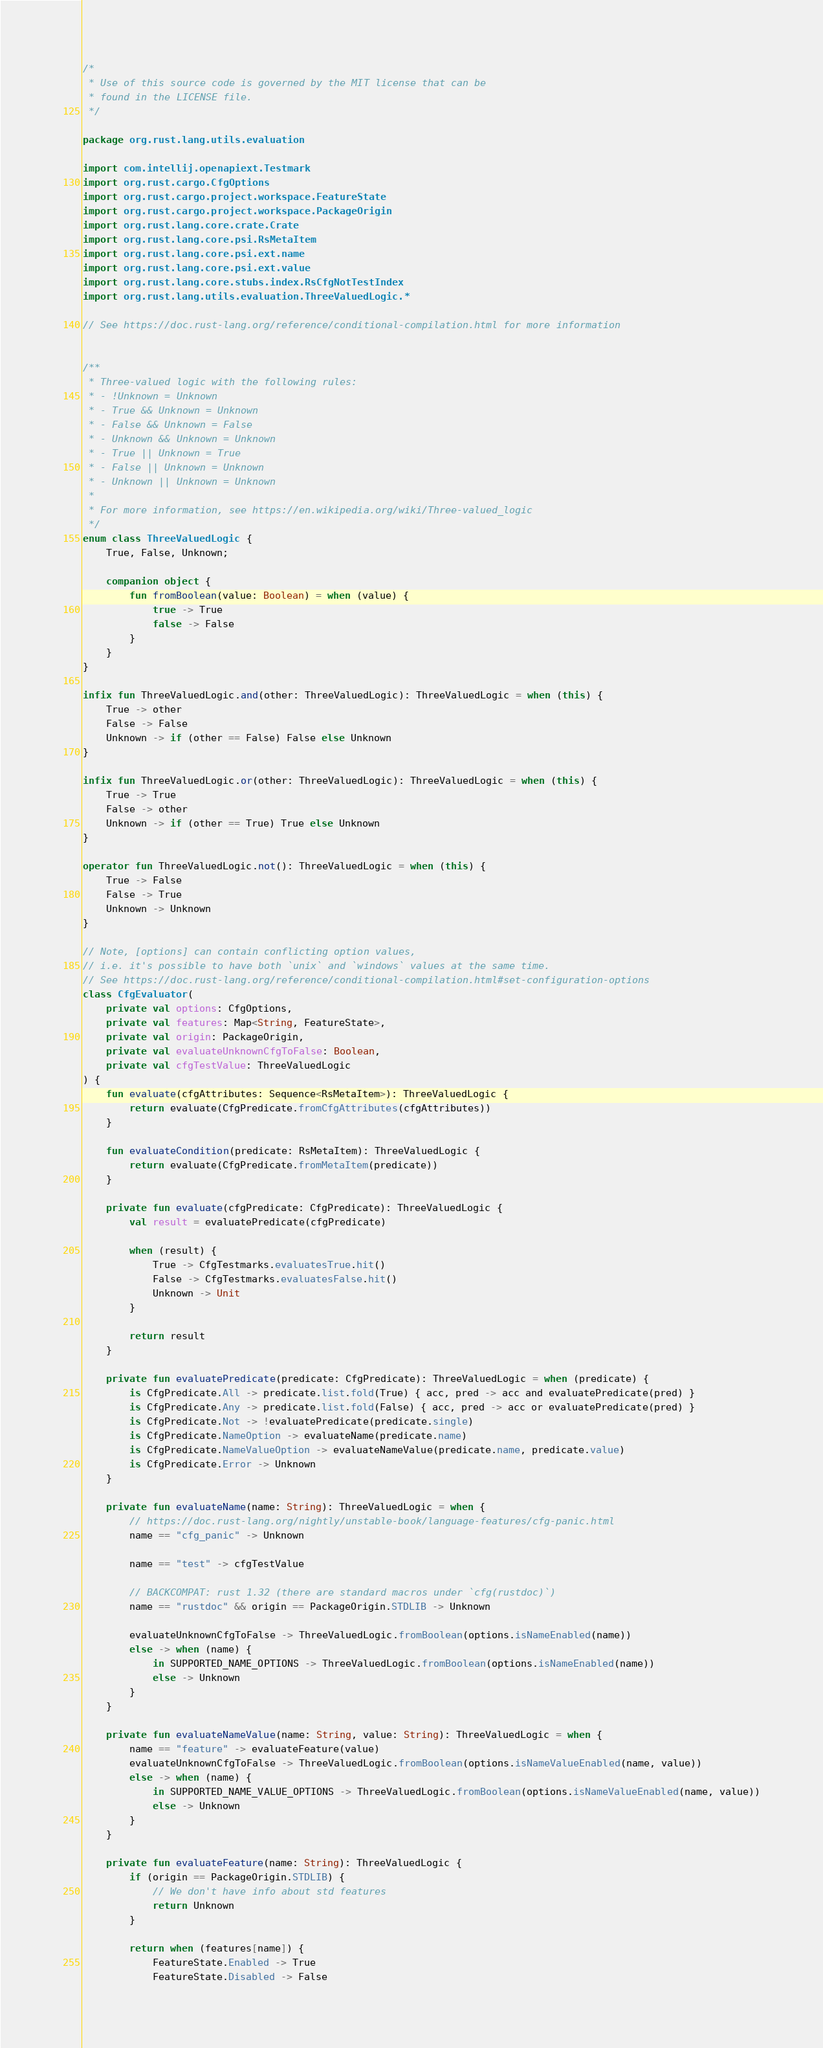<code> <loc_0><loc_0><loc_500><loc_500><_Kotlin_>/*
 * Use of this source code is governed by the MIT license that can be
 * found in the LICENSE file.
 */

package org.rust.lang.utils.evaluation

import com.intellij.openapiext.Testmark
import org.rust.cargo.CfgOptions
import org.rust.cargo.project.workspace.FeatureState
import org.rust.cargo.project.workspace.PackageOrigin
import org.rust.lang.core.crate.Crate
import org.rust.lang.core.psi.RsMetaItem
import org.rust.lang.core.psi.ext.name
import org.rust.lang.core.psi.ext.value
import org.rust.lang.core.stubs.index.RsCfgNotTestIndex
import org.rust.lang.utils.evaluation.ThreeValuedLogic.*

// See https://doc.rust-lang.org/reference/conditional-compilation.html for more information


/**
 * Three-valued logic with the following rules:
 * - !Unknown = Unknown
 * - True && Unknown = Unknown
 * - False && Unknown = False
 * - Unknown && Unknown = Unknown
 * - True || Unknown = True
 * - False || Unknown = Unknown
 * - Unknown || Unknown = Unknown
 *
 * For more information, see https://en.wikipedia.org/wiki/Three-valued_logic
 */
enum class ThreeValuedLogic {
    True, False, Unknown;

    companion object {
        fun fromBoolean(value: Boolean) = when (value) {
            true -> True
            false -> False
        }
    }
}

infix fun ThreeValuedLogic.and(other: ThreeValuedLogic): ThreeValuedLogic = when (this) {
    True -> other
    False -> False
    Unknown -> if (other == False) False else Unknown
}

infix fun ThreeValuedLogic.or(other: ThreeValuedLogic): ThreeValuedLogic = when (this) {
    True -> True
    False -> other
    Unknown -> if (other == True) True else Unknown
}

operator fun ThreeValuedLogic.not(): ThreeValuedLogic = when (this) {
    True -> False
    False -> True
    Unknown -> Unknown
}

// Note, [options] can contain conflicting option values,
// i.e. it's possible to have both `unix` and `windows` values at the same time.
// See https://doc.rust-lang.org/reference/conditional-compilation.html#set-configuration-options
class CfgEvaluator(
    private val options: CfgOptions,
    private val features: Map<String, FeatureState>,
    private val origin: PackageOrigin,
    private val evaluateUnknownCfgToFalse: Boolean,
    private val cfgTestValue: ThreeValuedLogic
) {
    fun evaluate(cfgAttributes: Sequence<RsMetaItem>): ThreeValuedLogic {
        return evaluate(CfgPredicate.fromCfgAttributes(cfgAttributes))
    }

    fun evaluateCondition(predicate: RsMetaItem): ThreeValuedLogic {
        return evaluate(CfgPredicate.fromMetaItem(predicate))
    }

    private fun evaluate(cfgPredicate: CfgPredicate): ThreeValuedLogic {
        val result = evaluatePredicate(cfgPredicate)

        when (result) {
            True -> CfgTestmarks.evaluatesTrue.hit()
            False -> CfgTestmarks.evaluatesFalse.hit()
            Unknown -> Unit
        }

        return result
    }

    private fun evaluatePredicate(predicate: CfgPredicate): ThreeValuedLogic = when (predicate) {
        is CfgPredicate.All -> predicate.list.fold(True) { acc, pred -> acc and evaluatePredicate(pred) }
        is CfgPredicate.Any -> predicate.list.fold(False) { acc, pred -> acc or evaluatePredicate(pred) }
        is CfgPredicate.Not -> !evaluatePredicate(predicate.single)
        is CfgPredicate.NameOption -> evaluateName(predicate.name)
        is CfgPredicate.NameValueOption -> evaluateNameValue(predicate.name, predicate.value)
        is CfgPredicate.Error -> Unknown
    }

    private fun evaluateName(name: String): ThreeValuedLogic = when {
        // https://doc.rust-lang.org/nightly/unstable-book/language-features/cfg-panic.html
        name == "cfg_panic" -> Unknown

        name == "test" -> cfgTestValue

        // BACKCOMPAT: rust 1.32 (there are standard macros under `cfg(rustdoc)`)
        name == "rustdoc" && origin == PackageOrigin.STDLIB -> Unknown

        evaluateUnknownCfgToFalse -> ThreeValuedLogic.fromBoolean(options.isNameEnabled(name))
        else -> when (name) {
            in SUPPORTED_NAME_OPTIONS -> ThreeValuedLogic.fromBoolean(options.isNameEnabled(name))
            else -> Unknown
        }
    }

    private fun evaluateNameValue(name: String, value: String): ThreeValuedLogic = when {
        name == "feature" -> evaluateFeature(value)
        evaluateUnknownCfgToFalse -> ThreeValuedLogic.fromBoolean(options.isNameValueEnabled(name, value))
        else -> when (name) {
            in SUPPORTED_NAME_VALUE_OPTIONS -> ThreeValuedLogic.fromBoolean(options.isNameValueEnabled(name, value))
            else -> Unknown
        }
    }

    private fun evaluateFeature(name: String): ThreeValuedLogic {
        if (origin == PackageOrigin.STDLIB) {
            // We don't have info about std features
            return Unknown
        }

        return when (features[name]) {
            FeatureState.Enabled -> True
            FeatureState.Disabled -> False</code> 